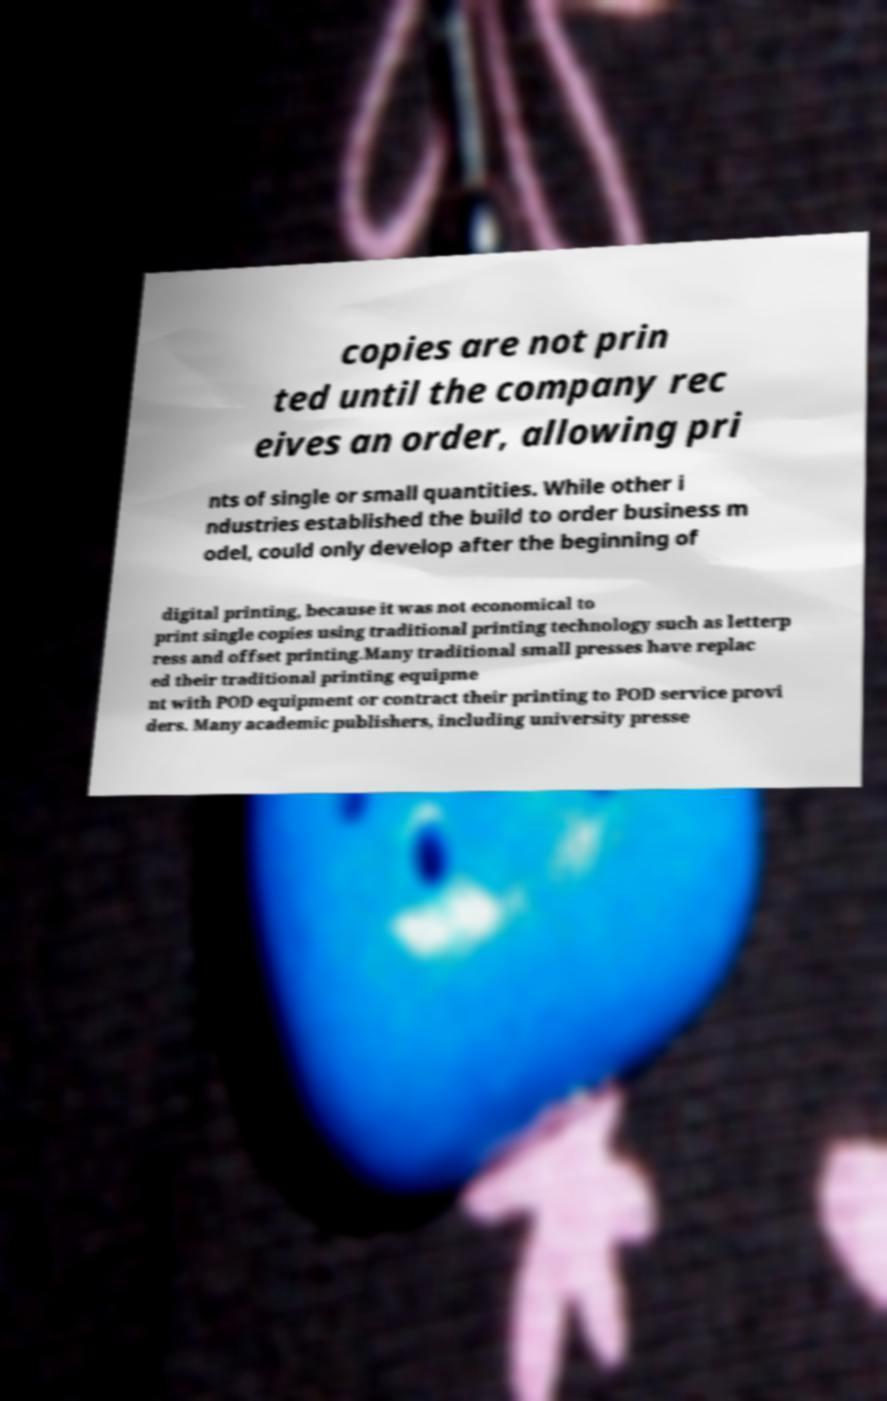Could you assist in decoding the text presented in this image and type it out clearly? copies are not prin ted until the company rec eives an order, allowing pri nts of single or small quantities. While other i ndustries established the build to order business m odel, could only develop after the beginning of digital printing, because it was not economical to print single copies using traditional printing technology such as letterp ress and offset printing.Many traditional small presses have replac ed their traditional printing equipme nt with POD equipment or contract their printing to POD service provi ders. Many academic publishers, including university presse 